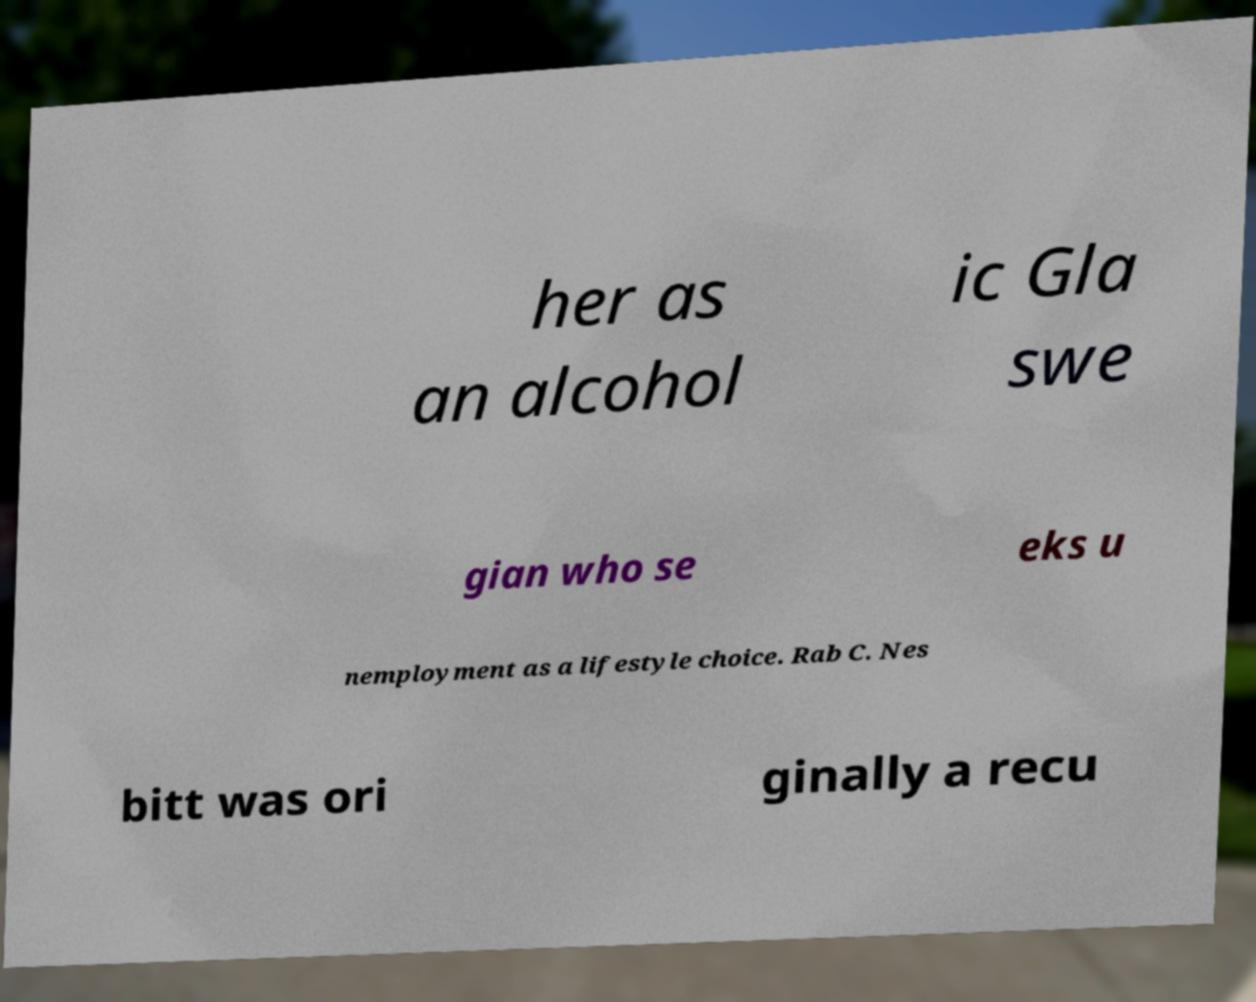Please identify and transcribe the text found in this image. her as an alcohol ic Gla swe gian who se eks u nemployment as a lifestyle choice. Rab C. Nes bitt was ori ginally a recu 